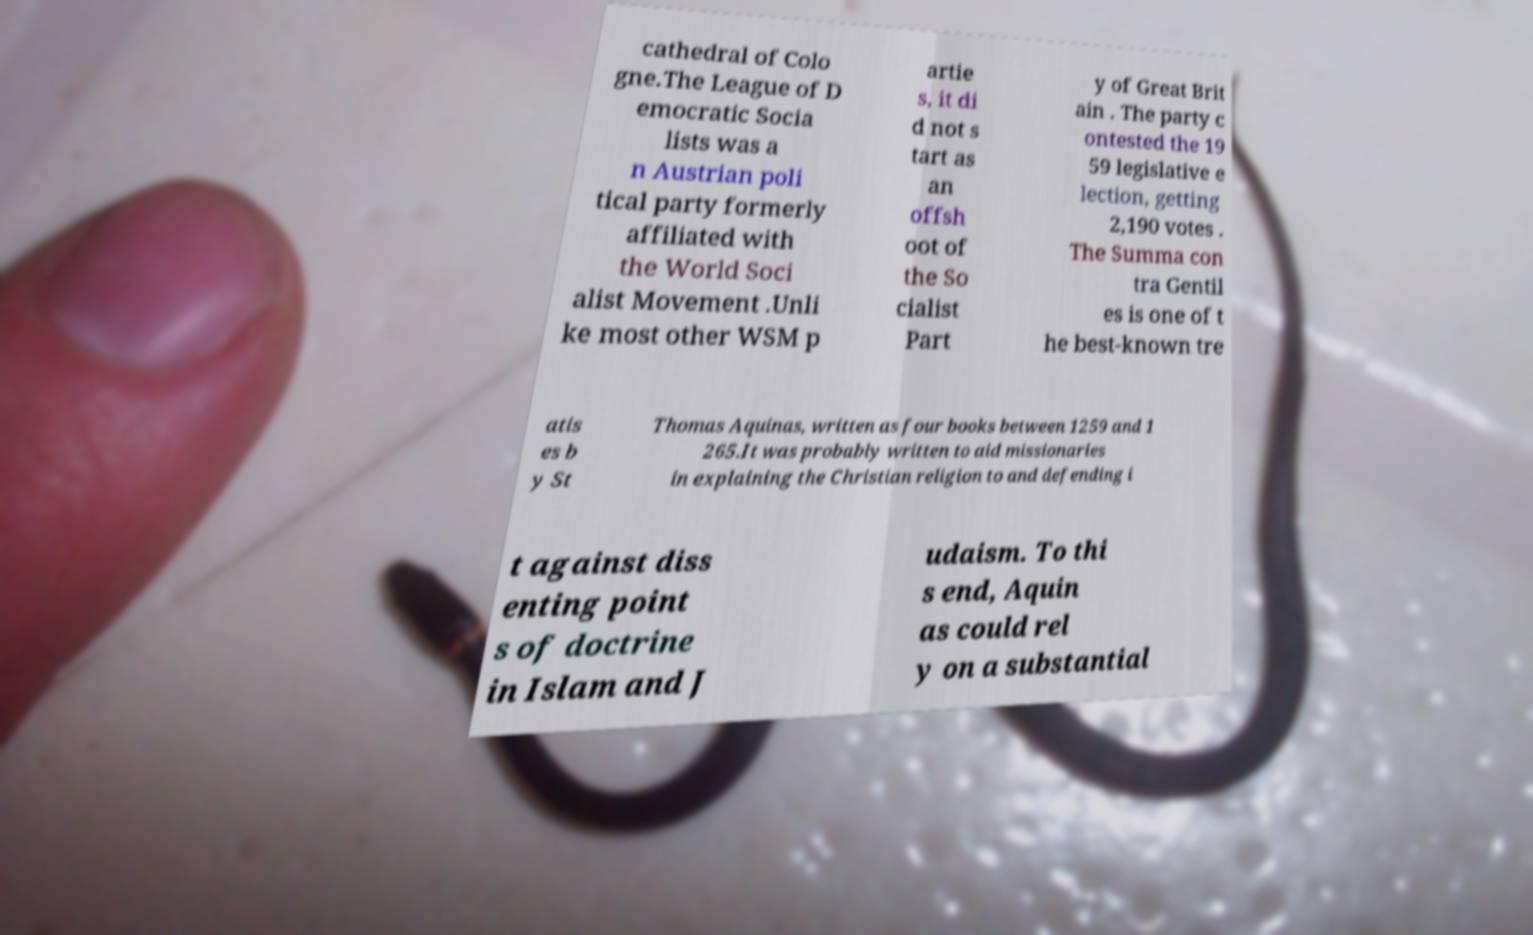Could you assist in decoding the text presented in this image and type it out clearly? cathedral of Colo gne.The League of D emocratic Socia lists was a n Austrian poli tical party formerly affiliated with the World Soci alist Movement .Unli ke most other WSM p artie s, it di d not s tart as an offsh oot of the So cialist Part y of Great Brit ain . The party c ontested the 19 59 legislative e lection, getting 2,190 votes . The Summa con tra Gentil es is one of t he best-known tre atis es b y St Thomas Aquinas, written as four books between 1259 and 1 265.It was probably written to aid missionaries in explaining the Christian religion to and defending i t against diss enting point s of doctrine in Islam and J udaism. To thi s end, Aquin as could rel y on a substantial 